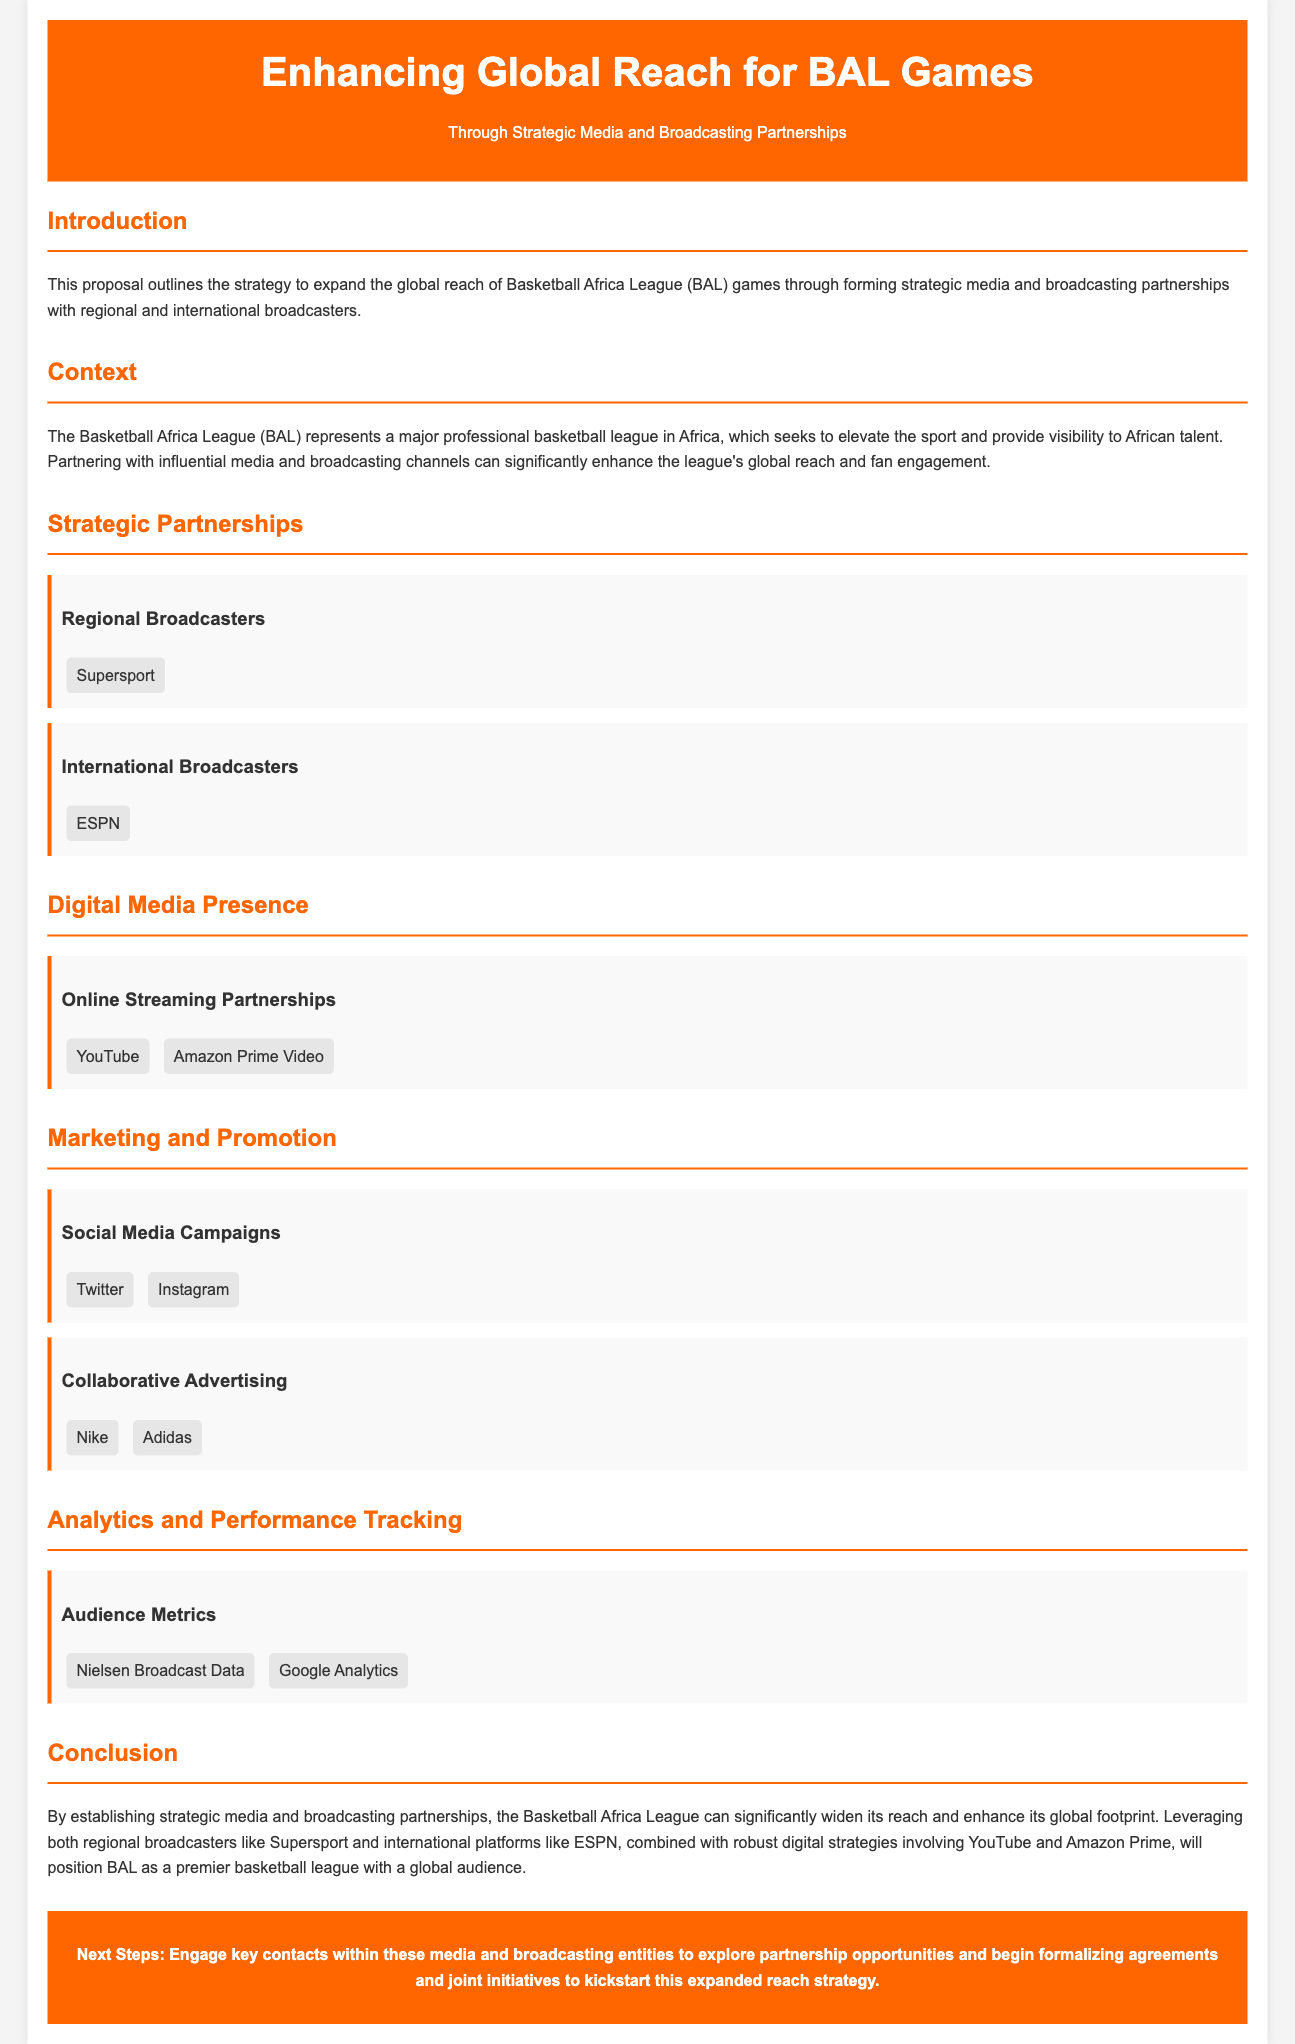What is the main goal of the proposal? The proposal aims to expand the global reach of BAL games through strategic media and broadcasting partnerships.
Answer: Expand global reach Who are the regional broadcasters mentioned? The document lists Supersport as the regional broadcaster.
Answer: Supersport Which international broadcaster is highlighted in the proposal? The proposal identifies ESPN as the international broadcaster.
Answer: ESPN What are the online streaming partners? The partners for online streaming mentioned are YouTube and Amazon Prime Video.
Answer: YouTube, Amazon Prime Video What social media platforms are suggested for campaigns? The document mentions Twitter and Instagram as social media platforms for campaigns.
Answer: Twitter, Instagram What is emphasized as a key aspect for tracking performance? The proposal highlights audience metrics as essential for tracking performance.
Answer: Audience metrics What marketing strategies are discussed in the proposal? The proposal discusses social media campaigns and collaborative advertising as marketing strategies.
Answer: Social media campaigns, collaborative advertising What is the next step suggested in the conclusion? The proposal suggests engaging key contacts within media entities to explore partnership opportunities.
Answer: Engage key contacts 